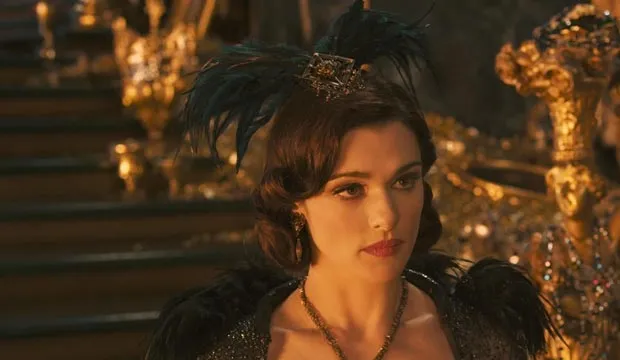Can you create a short story based on this image? Evanora, the Enchantress of the Golden Palace, stood before her throne, deep in thought. The gleaming gold of the palace mirrored her inner turmoil as she pondered over the prophecy foretold by the ancient seer. Her kingdom was at a crossroads, and her next move would determine its fate. She wore a crown adorned with black feathers, each one representing a fallen enemy, and her black and gold gown billowed around her like a dark cloud. She had to choose wisely, for one wrong step could lead to the kingdom's downfall. Evanora knew that the power to change destiny was within her grasp, but she had to act swiftly and decisively. The time for contemplation was over; the time for action had arrived. 